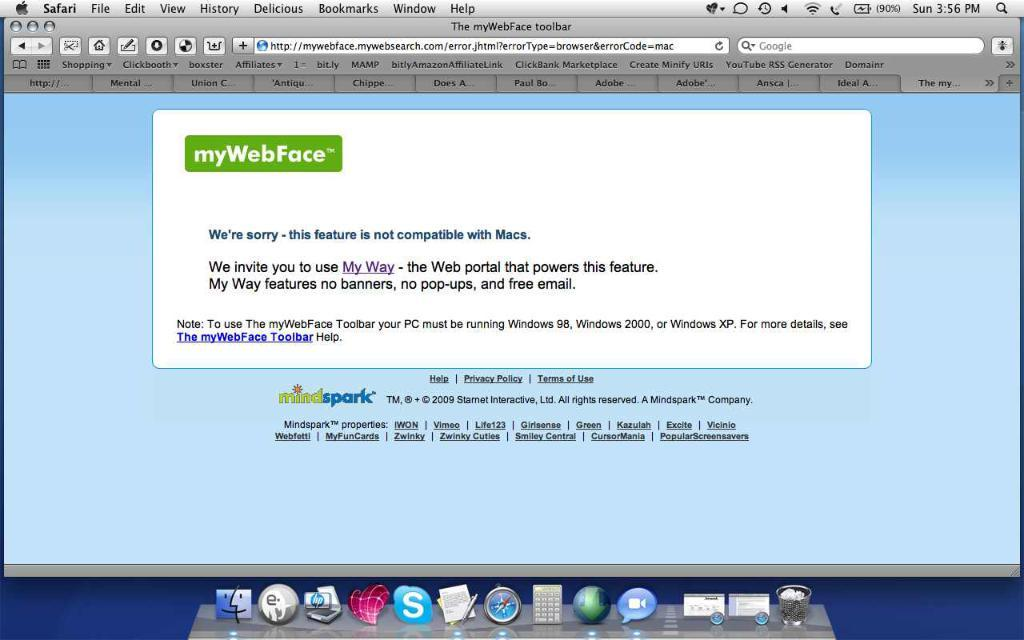<image>
Render a clear and concise summary of the photo. An application that claims it is not compatible with Macs. 